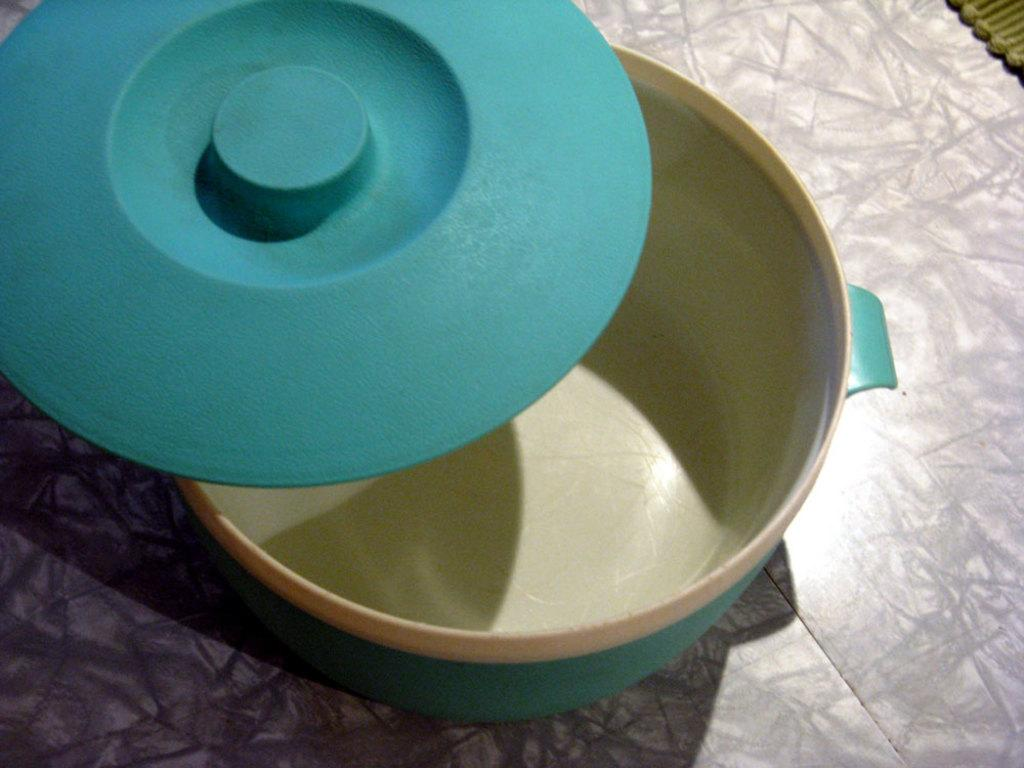What object is present in the image that has a lid? There is a bowl in the image that has a blue lid. What type of bowl is depicted in the image? The bowl resembles a hot box. What part of the room can be seen at the bottom of the image? The floor is visible at the bottom of the image. What type of railway is visible in the image? There is no railway present in the image. Can you describe the design of the bowl's lid in the image? The facts provided do not mention the design of the bowl's lid, only its color (blue). 